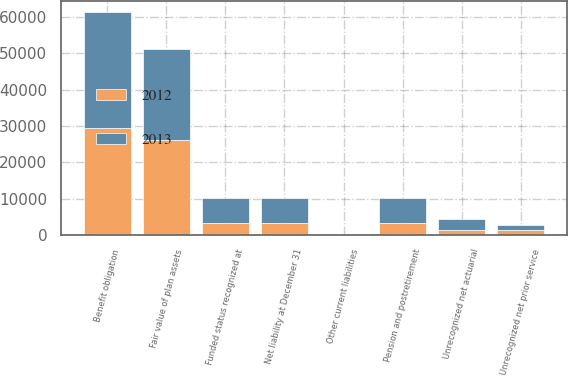Convert chart to OTSL. <chart><loc_0><loc_0><loc_500><loc_500><stacked_bar_chart><ecel><fcel>Fair value of plan assets<fcel>Benefit obligation<fcel>Funded status recognized at<fcel>Other current liabilities<fcel>Pension and postretirement<fcel>Net liability at December 31<fcel>Unrecognized net prior service<fcel>Unrecognized net actuarial<nl><fcel>2012<fcel>26224<fcel>29508<fcel>3284<fcel>16<fcel>3268<fcel>3284<fcel>1286<fcel>1233<nl><fcel>2013<fcel>24941<fcel>31868<fcel>6927<fcel>14<fcel>6913<fcel>6927<fcel>1318<fcel>3187<nl></chart> 